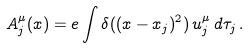<formula> <loc_0><loc_0><loc_500><loc_500>A ^ { \mu } _ { j } ( x ) = e \int \delta ( ( x - x _ { j } ) ^ { 2 } ) \, u ^ { \mu } _ { j } \, d \tau _ { j } \, .</formula> 